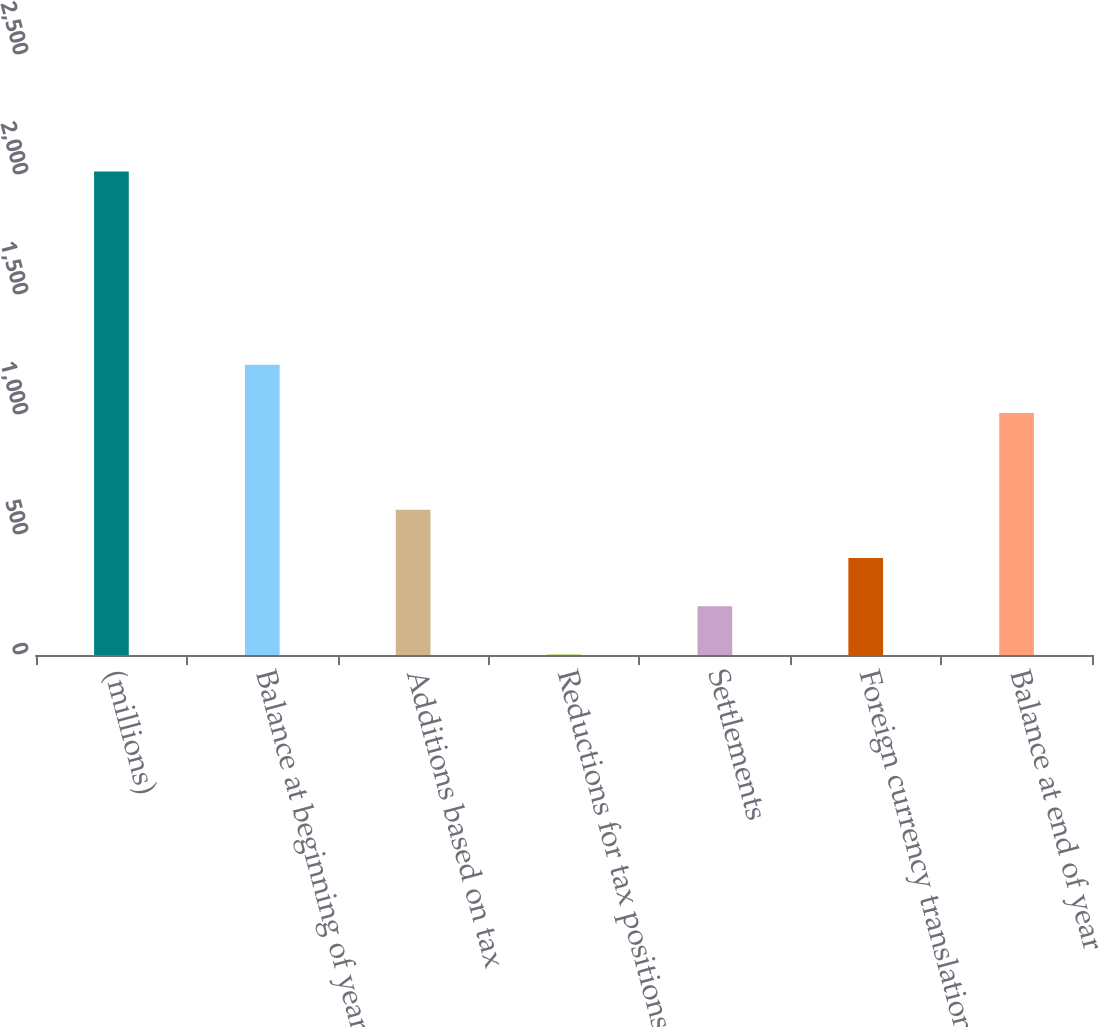Convert chart to OTSL. <chart><loc_0><loc_0><loc_500><loc_500><bar_chart><fcel>(millions)<fcel>Balance at beginning of year<fcel>Additions based on tax<fcel>Reductions for tax positions<fcel>Settlements<fcel>Foreign currency translation<fcel>Balance at end of year<nl><fcel>2015<fcel>1209.64<fcel>605.62<fcel>1.6<fcel>202.94<fcel>404.28<fcel>1008.3<nl></chart> 